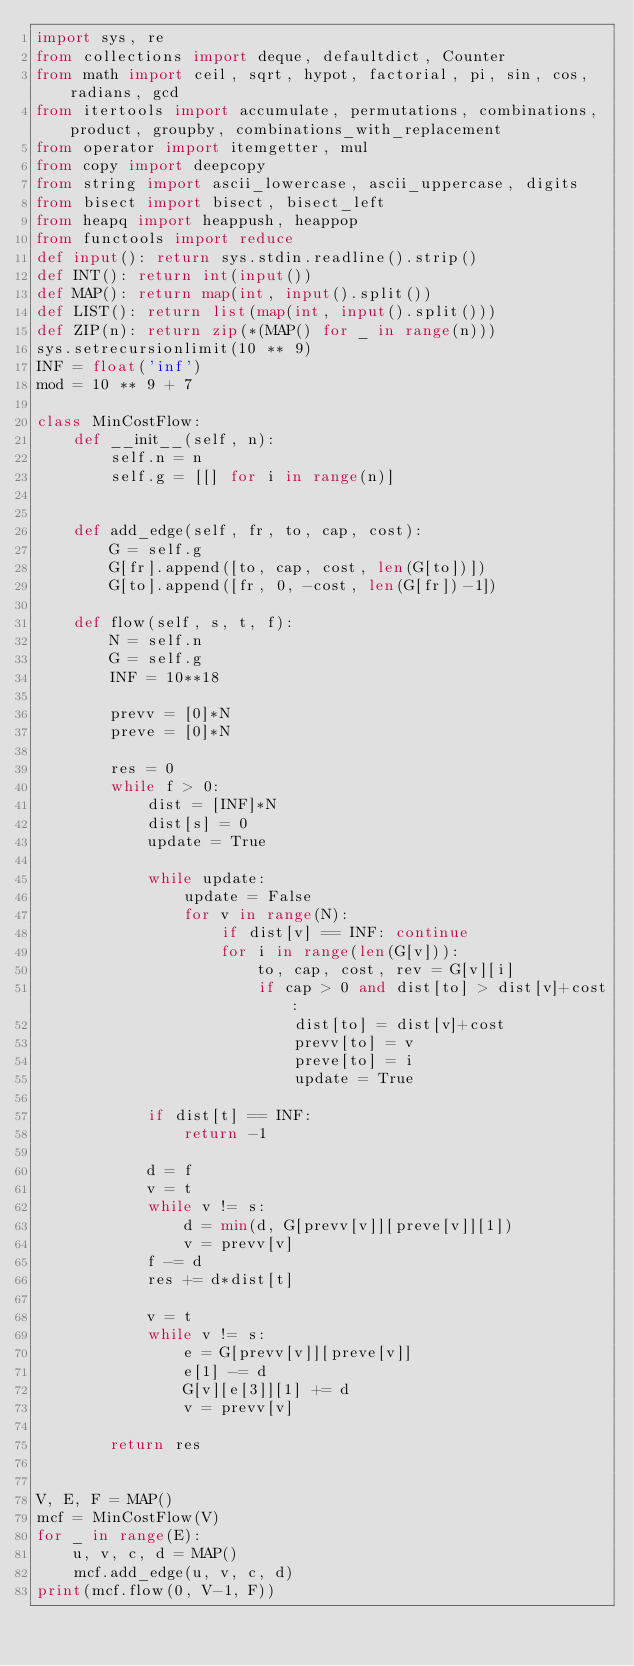Convert code to text. <code><loc_0><loc_0><loc_500><loc_500><_Python_>import sys, re
from collections import deque, defaultdict, Counter
from math import ceil, sqrt, hypot, factorial, pi, sin, cos, radians, gcd
from itertools import accumulate, permutations, combinations, product, groupby, combinations_with_replacement
from operator import itemgetter, mul
from copy import deepcopy
from string import ascii_lowercase, ascii_uppercase, digits
from bisect import bisect, bisect_left
from heapq import heappush, heappop
from functools import reduce
def input(): return sys.stdin.readline().strip()
def INT(): return int(input())
def MAP(): return map(int, input().split())
def LIST(): return list(map(int, input().split()))
def ZIP(n): return zip(*(MAP() for _ in range(n)))
sys.setrecursionlimit(10 ** 9)
INF = float('inf')
mod = 10 ** 9 + 7

class MinCostFlow:
    def __init__(self, n):
        self.n = n
        self.g = [[] for i in range(n)]


    def add_edge(self, fr, to, cap, cost):
        G = self.g
        G[fr].append([to, cap, cost, len(G[to])])
        G[to].append([fr, 0, -cost, len(G[fr])-1])

    def flow(self, s, t, f):
        N = self.n
        G = self.g
        INF = 10**18

        prevv = [0]*N
        preve = [0]*N

        res = 0
        while f > 0:
            dist = [INF]*N
            dist[s] = 0
            update = True

            while update:
                update = False
                for v in range(N):
                    if dist[v] == INF: continue
                    for i in range(len(G[v])):
                        to, cap, cost, rev = G[v][i]
                        if cap > 0 and dist[to] > dist[v]+cost:
                            dist[to] = dist[v]+cost
                            prevv[to] = v
                            preve[to] = i
                            update = True

            if dist[t] == INF:
                return -1

            d = f
            v = t
            while v != s:
                d = min(d, G[prevv[v]][preve[v]][1])
                v = prevv[v]
            f -= d
            res += d*dist[t]

            v = t
            while v != s:
                e = G[prevv[v]][preve[v]]
                e[1] -= d
                G[v][e[3]][1] += d
                v = prevv[v]

        return res
            

V, E, F = MAP()
mcf = MinCostFlow(V)
for _ in range(E):
    u, v, c, d = MAP()
    mcf.add_edge(u, v, c, d)
print(mcf.flow(0, V-1, F))

</code> 